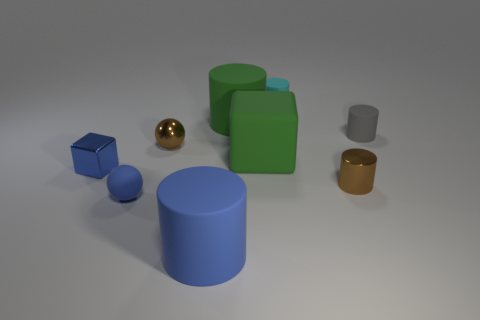What size is the shiny sphere?
Offer a terse response. Small. There is a tiny metal thing that is behind the blue shiny object; what number of big matte objects are in front of it?
Provide a succinct answer. 2. What shape is the small object that is both behind the tiny blue shiny object and to the left of the blue cylinder?
Offer a very short reply. Sphere. What number of tiny things are the same color as the small matte sphere?
Make the answer very short. 1. Are there any blue rubber balls that are behind the tiny rubber object that is to the left of the small shiny thing that is behind the blue metallic thing?
Make the answer very short. No. There is a rubber object that is both in front of the brown metallic cylinder and to the right of the tiny brown shiny sphere; how big is it?
Your response must be concise. Large. How many big green blocks have the same material as the large blue thing?
Provide a short and direct response. 1. How many balls are either big blue things or small blue metallic things?
Provide a short and direct response. 0. There is a object that is behind the big cylinder that is right of the blue thing that is right of the shiny sphere; how big is it?
Your answer should be very brief. Small. The big object that is on the right side of the blue cylinder and to the left of the green block is what color?
Give a very brief answer. Green. 